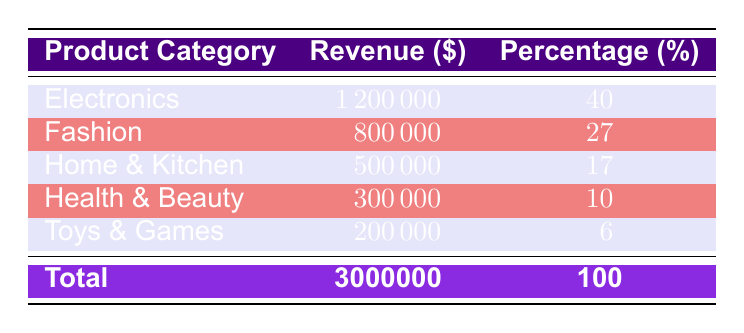What is the revenue for the Fashion product category? The table specifies that the revenue for the Fashion category is presented directly under the Revenue column corresponding to Fashion, which is 800000.
Answer: 800000 Which product category contributes the least to total revenue? By comparing the revenue values in the table, the lowest value is for the Toys & Games category, which has a revenue of 200000.
Answer: Toys & Games What is the total revenue for Electronics and Fashion combined? To find the total revenue for both categories, we sum their revenues: 1200000 (Electronics) + 800000 (Fashion) = 2000000.
Answer: 2000000 Is the revenue from Health & Beauty greater than that from Toys & Games? Comparing the two values in the table shows that Health & Beauty has a revenue of 300000, while Toys & Games has a revenue of only 200000. Since 300000 is greater than 200000, the statement is true.
Answer: Yes What percentage of total revenue does Home & Kitchen represent? The percentage for Home & Kitchen is listed in the table as 17, and since the total revenue is 3000000, this means Home & Kitchen accounts for 17% of total revenue.
Answer: 17 What is the average revenue across all product categories? To find the average, we first add all the revenues: 1200000 + 800000 + 500000 + 300000 + 200000 = 3000000. There are 5 categories, so we divide the total revenue by 5: 3000000 / 5 = 600000.
Answer: 600000 Which two categories account for over 50% of total revenue together? Calculating the sums: Electronics (1200000) + Fashion (800000) = 2000000 (which is 66.67% of total revenue), and adding the revenue from Home & Kitchen (500000) makes 2500000 (83.33%). Hence, Electronics and Fashion together exceed 50%.
Answer: Electronics and Fashion How much revenue does Health & Beauty generate in relation to the total revenue? The revenue for Health & Beauty is 300000 and the total revenue is 3000000. Therefore, Health & Beauty contributes 300000/3000000, which is 10% of total revenue.
Answer: 10% 